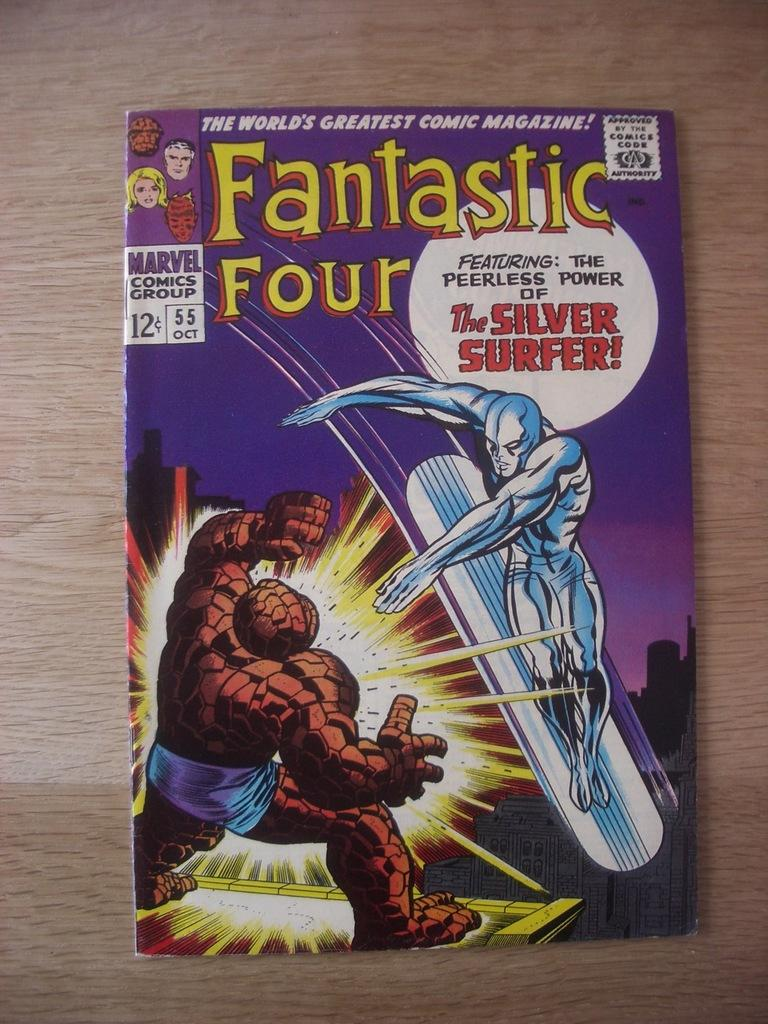<image>
Create a compact narrative representing the image presented. A Fantastic Four comic book features The Silver Surfer 